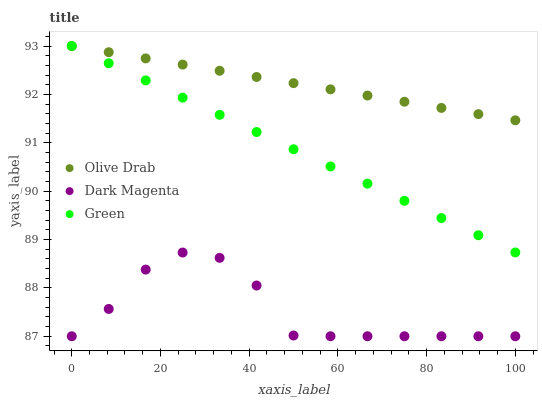Does Dark Magenta have the minimum area under the curve?
Answer yes or no. Yes. Does Olive Drab have the maximum area under the curve?
Answer yes or no. Yes. Does Olive Drab have the minimum area under the curve?
Answer yes or no. No. Does Dark Magenta have the maximum area under the curve?
Answer yes or no. No. Is Olive Drab the smoothest?
Answer yes or no. Yes. Is Dark Magenta the roughest?
Answer yes or no. Yes. Is Dark Magenta the smoothest?
Answer yes or no. No. Is Olive Drab the roughest?
Answer yes or no. No. Does Dark Magenta have the lowest value?
Answer yes or no. Yes. Does Olive Drab have the lowest value?
Answer yes or no. No. Does Olive Drab have the highest value?
Answer yes or no. Yes. Does Dark Magenta have the highest value?
Answer yes or no. No. Is Dark Magenta less than Green?
Answer yes or no. Yes. Is Olive Drab greater than Dark Magenta?
Answer yes or no. Yes. Does Olive Drab intersect Green?
Answer yes or no. Yes. Is Olive Drab less than Green?
Answer yes or no. No. Is Olive Drab greater than Green?
Answer yes or no. No. Does Dark Magenta intersect Green?
Answer yes or no. No. 